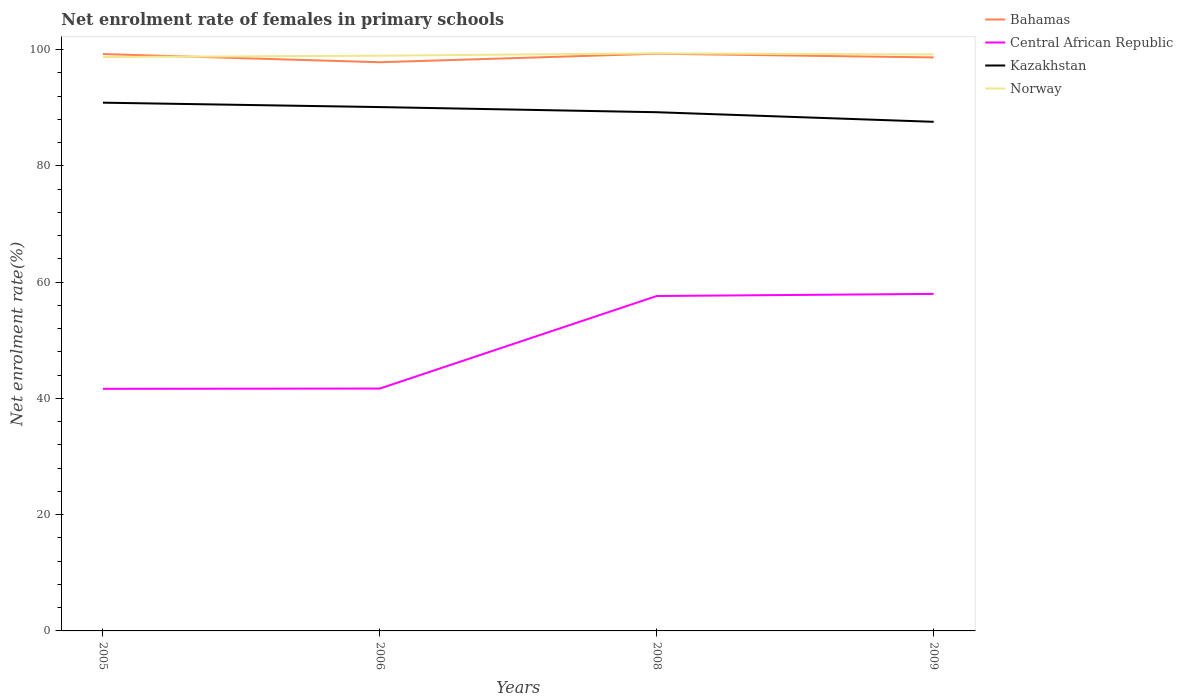Does the line corresponding to Norway intersect with the line corresponding to Bahamas?
Offer a terse response. Yes. Across all years, what is the maximum net enrolment rate of females in primary schools in Norway?
Offer a very short reply. 98.74. What is the total net enrolment rate of females in primary schools in Central African Republic in the graph?
Offer a terse response. -0.05. What is the difference between the highest and the second highest net enrolment rate of females in primary schools in Bahamas?
Give a very brief answer. 1.46. How many lines are there?
Provide a short and direct response. 4. Does the graph contain grids?
Provide a short and direct response. No. How many legend labels are there?
Provide a succinct answer. 4. How are the legend labels stacked?
Your response must be concise. Vertical. What is the title of the graph?
Keep it short and to the point. Net enrolment rate of females in primary schools. What is the label or title of the Y-axis?
Provide a succinct answer. Net enrolment rate(%). What is the Net enrolment rate(%) of Bahamas in 2005?
Ensure brevity in your answer.  99.25. What is the Net enrolment rate(%) in Central African Republic in 2005?
Your answer should be compact. 41.65. What is the Net enrolment rate(%) in Kazakhstan in 2005?
Ensure brevity in your answer.  90.89. What is the Net enrolment rate(%) in Norway in 2005?
Ensure brevity in your answer.  98.74. What is the Net enrolment rate(%) in Bahamas in 2006?
Keep it short and to the point. 97.85. What is the Net enrolment rate(%) of Central African Republic in 2006?
Offer a very short reply. 41.7. What is the Net enrolment rate(%) in Kazakhstan in 2006?
Keep it short and to the point. 90.13. What is the Net enrolment rate(%) of Norway in 2006?
Ensure brevity in your answer.  98.97. What is the Net enrolment rate(%) in Bahamas in 2008?
Give a very brief answer. 99.31. What is the Net enrolment rate(%) in Central African Republic in 2008?
Provide a short and direct response. 57.63. What is the Net enrolment rate(%) in Kazakhstan in 2008?
Offer a terse response. 89.25. What is the Net enrolment rate(%) of Norway in 2008?
Your answer should be very brief. 99.38. What is the Net enrolment rate(%) in Bahamas in 2009?
Give a very brief answer. 98.68. What is the Net enrolment rate(%) of Central African Republic in 2009?
Provide a short and direct response. 57.99. What is the Net enrolment rate(%) in Kazakhstan in 2009?
Provide a short and direct response. 87.6. What is the Net enrolment rate(%) in Norway in 2009?
Offer a very short reply. 99.19. Across all years, what is the maximum Net enrolment rate(%) in Bahamas?
Provide a succinct answer. 99.31. Across all years, what is the maximum Net enrolment rate(%) in Central African Republic?
Keep it short and to the point. 57.99. Across all years, what is the maximum Net enrolment rate(%) in Kazakhstan?
Your answer should be very brief. 90.89. Across all years, what is the maximum Net enrolment rate(%) in Norway?
Provide a short and direct response. 99.38. Across all years, what is the minimum Net enrolment rate(%) in Bahamas?
Offer a very short reply. 97.85. Across all years, what is the minimum Net enrolment rate(%) of Central African Republic?
Your answer should be compact. 41.65. Across all years, what is the minimum Net enrolment rate(%) of Kazakhstan?
Offer a terse response. 87.6. Across all years, what is the minimum Net enrolment rate(%) of Norway?
Provide a succinct answer. 98.74. What is the total Net enrolment rate(%) of Bahamas in the graph?
Offer a terse response. 395.09. What is the total Net enrolment rate(%) in Central African Republic in the graph?
Make the answer very short. 198.97. What is the total Net enrolment rate(%) of Kazakhstan in the graph?
Offer a terse response. 357.87. What is the total Net enrolment rate(%) in Norway in the graph?
Provide a short and direct response. 396.28. What is the difference between the Net enrolment rate(%) in Bahamas in 2005 and that in 2006?
Provide a short and direct response. 1.4. What is the difference between the Net enrolment rate(%) of Central African Republic in 2005 and that in 2006?
Your response must be concise. -0.05. What is the difference between the Net enrolment rate(%) in Kazakhstan in 2005 and that in 2006?
Provide a succinct answer. 0.76. What is the difference between the Net enrolment rate(%) of Norway in 2005 and that in 2006?
Give a very brief answer. -0.23. What is the difference between the Net enrolment rate(%) in Bahamas in 2005 and that in 2008?
Your response must be concise. -0.06. What is the difference between the Net enrolment rate(%) in Central African Republic in 2005 and that in 2008?
Your response must be concise. -15.97. What is the difference between the Net enrolment rate(%) in Kazakhstan in 2005 and that in 2008?
Give a very brief answer. 1.64. What is the difference between the Net enrolment rate(%) of Norway in 2005 and that in 2008?
Offer a very short reply. -0.64. What is the difference between the Net enrolment rate(%) of Bahamas in 2005 and that in 2009?
Keep it short and to the point. 0.58. What is the difference between the Net enrolment rate(%) of Central African Republic in 2005 and that in 2009?
Ensure brevity in your answer.  -16.33. What is the difference between the Net enrolment rate(%) in Kazakhstan in 2005 and that in 2009?
Ensure brevity in your answer.  3.3. What is the difference between the Net enrolment rate(%) in Norway in 2005 and that in 2009?
Make the answer very short. -0.44. What is the difference between the Net enrolment rate(%) of Bahamas in 2006 and that in 2008?
Make the answer very short. -1.46. What is the difference between the Net enrolment rate(%) of Central African Republic in 2006 and that in 2008?
Give a very brief answer. -15.92. What is the difference between the Net enrolment rate(%) of Kazakhstan in 2006 and that in 2008?
Give a very brief answer. 0.88. What is the difference between the Net enrolment rate(%) of Norway in 2006 and that in 2008?
Offer a terse response. -0.4. What is the difference between the Net enrolment rate(%) in Bahamas in 2006 and that in 2009?
Your response must be concise. -0.83. What is the difference between the Net enrolment rate(%) in Central African Republic in 2006 and that in 2009?
Provide a short and direct response. -16.29. What is the difference between the Net enrolment rate(%) in Kazakhstan in 2006 and that in 2009?
Ensure brevity in your answer.  2.54. What is the difference between the Net enrolment rate(%) in Norway in 2006 and that in 2009?
Provide a short and direct response. -0.21. What is the difference between the Net enrolment rate(%) in Bahamas in 2008 and that in 2009?
Ensure brevity in your answer.  0.63. What is the difference between the Net enrolment rate(%) of Central African Republic in 2008 and that in 2009?
Keep it short and to the point. -0.36. What is the difference between the Net enrolment rate(%) in Kazakhstan in 2008 and that in 2009?
Offer a terse response. 1.65. What is the difference between the Net enrolment rate(%) in Norway in 2008 and that in 2009?
Your answer should be compact. 0.19. What is the difference between the Net enrolment rate(%) in Bahamas in 2005 and the Net enrolment rate(%) in Central African Republic in 2006?
Ensure brevity in your answer.  57.55. What is the difference between the Net enrolment rate(%) of Bahamas in 2005 and the Net enrolment rate(%) of Kazakhstan in 2006?
Give a very brief answer. 9.12. What is the difference between the Net enrolment rate(%) in Bahamas in 2005 and the Net enrolment rate(%) in Norway in 2006?
Provide a succinct answer. 0.28. What is the difference between the Net enrolment rate(%) in Central African Republic in 2005 and the Net enrolment rate(%) in Kazakhstan in 2006?
Your answer should be very brief. -48.48. What is the difference between the Net enrolment rate(%) in Central African Republic in 2005 and the Net enrolment rate(%) in Norway in 2006?
Your response must be concise. -57.32. What is the difference between the Net enrolment rate(%) in Kazakhstan in 2005 and the Net enrolment rate(%) in Norway in 2006?
Make the answer very short. -8.08. What is the difference between the Net enrolment rate(%) of Bahamas in 2005 and the Net enrolment rate(%) of Central African Republic in 2008?
Your response must be concise. 41.63. What is the difference between the Net enrolment rate(%) in Bahamas in 2005 and the Net enrolment rate(%) in Kazakhstan in 2008?
Your answer should be very brief. 10.01. What is the difference between the Net enrolment rate(%) in Bahamas in 2005 and the Net enrolment rate(%) in Norway in 2008?
Make the answer very short. -0.12. What is the difference between the Net enrolment rate(%) in Central African Republic in 2005 and the Net enrolment rate(%) in Kazakhstan in 2008?
Provide a succinct answer. -47.59. What is the difference between the Net enrolment rate(%) of Central African Republic in 2005 and the Net enrolment rate(%) of Norway in 2008?
Give a very brief answer. -57.72. What is the difference between the Net enrolment rate(%) in Kazakhstan in 2005 and the Net enrolment rate(%) in Norway in 2008?
Your answer should be compact. -8.49. What is the difference between the Net enrolment rate(%) of Bahamas in 2005 and the Net enrolment rate(%) of Central African Republic in 2009?
Provide a short and direct response. 41.26. What is the difference between the Net enrolment rate(%) of Bahamas in 2005 and the Net enrolment rate(%) of Kazakhstan in 2009?
Provide a short and direct response. 11.66. What is the difference between the Net enrolment rate(%) in Bahamas in 2005 and the Net enrolment rate(%) in Norway in 2009?
Your response must be concise. 0.07. What is the difference between the Net enrolment rate(%) in Central African Republic in 2005 and the Net enrolment rate(%) in Kazakhstan in 2009?
Your answer should be compact. -45.94. What is the difference between the Net enrolment rate(%) in Central African Republic in 2005 and the Net enrolment rate(%) in Norway in 2009?
Ensure brevity in your answer.  -57.53. What is the difference between the Net enrolment rate(%) of Kazakhstan in 2005 and the Net enrolment rate(%) of Norway in 2009?
Your answer should be very brief. -8.29. What is the difference between the Net enrolment rate(%) in Bahamas in 2006 and the Net enrolment rate(%) in Central African Republic in 2008?
Your answer should be very brief. 40.22. What is the difference between the Net enrolment rate(%) of Bahamas in 2006 and the Net enrolment rate(%) of Kazakhstan in 2008?
Give a very brief answer. 8.6. What is the difference between the Net enrolment rate(%) in Bahamas in 2006 and the Net enrolment rate(%) in Norway in 2008?
Your response must be concise. -1.53. What is the difference between the Net enrolment rate(%) of Central African Republic in 2006 and the Net enrolment rate(%) of Kazakhstan in 2008?
Offer a terse response. -47.55. What is the difference between the Net enrolment rate(%) in Central African Republic in 2006 and the Net enrolment rate(%) in Norway in 2008?
Provide a succinct answer. -57.68. What is the difference between the Net enrolment rate(%) in Kazakhstan in 2006 and the Net enrolment rate(%) in Norway in 2008?
Keep it short and to the point. -9.25. What is the difference between the Net enrolment rate(%) of Bahamas in 2006 and the Net enrolment rate(%) of Central African Republic in 2009?
Make the answer very short. 39.86. What is the difference between the Net enrolment rate(%) of Bahamas in 2006 and the Net enrolment rate(%) of Kazakhstan in 2009?
Provide a short and direct response. 10.25. What is the difference between the Net enrolment rate(%) in Bahamas in 2006 and the Net enrolment rate(%) in Norway in 2009?
Give a very brief answer. -1.34. What is the difference between the Net enrolment rate(%) in Central African Republic in 2006 and the Net enrolment rate(%) in Kazakhstan in 2009?
Ensure brevity in your answer.  -45.89. What is the difference between the Net enrolment rate(%) of Central African Republic in 2006 and the Net enrolment rate(%) of Norway in 2009?
Keep it short and to the point. -57.48. What is the difference between the Net enrolment rate(%) of Kazakhstan in 2006 and the Net enrolment rate(%) of Norway in 2009?
Provide a succinct answer. -9.05. What is the difference between the Net enrolment rate(%) in Bahamas in 2008 and the Net enrolment rate(%) in Central African Republic in 2009?
Provide a short and direct response. 41.32. What is the difference between the Net enrolment rate(%) of Bahamas in 2008 and the Net enrolment rate(%) of Kazakhstan in 2009?
Your answer should be very brief. 11.72. What is the difference between the Net enrolment rate(%) of Bahamas in 2008 and the Net enrolment rate(%) of Norway in 2009?
Offer a very short reply. 0.13. What is the difference between the Net enrolment rate(%) in Central African Republic in 2008 and the Net enrolment rate(%) in Kazakhstan in 2009?
Your response must be concise. -29.97. What is the difference between the Net enrolment rate(%) in Central African Republic in 2008 and the Net enrolment rate(%) in Norway in 2009?
Provide a succinct answer. -41.56. What is the difference between the Net enrolment rate(%) of Kazakhstan in 2008 and the Net enrolment rate(%) of Norway in 2009?
Give a very brief answer. -9.94. What is the average Net enrolment rate(%) in Bahamas per year?
Your answer should be compact. 98.77. What is the average Net enrolment rate(%) in Central African Republic per year?
Your response must be concise. 49.74. What is the average Net enrolment rate(%) in Kazakhstan per year?
Give a very brief answer. 89.47. What is the average Net enrolment rate(%) of Norway per year?
Provide a succinct answer. 99.07. In the year 2005, what is the difference between the Net enrolment rate(%) of Bahamas and Net enrolment rate(%) of Central African Republic?
Give a very brief answer. 57.6. In the year 2005, what is the difference between the Net enrolment rate(%) of Bahamas and Net enrolment rate(%) of Kazakhstan?
Keep it short and to the point. 8.36. In the year 2005, what is the difference between the Net enrolment rate(%) in Bahamas and Net enrolment rate(%) in Norway?
Offer a terse response. 0.51. In the year 2005, what is the difference between the Net enrolment rate(%) in Central African Republic and Net enrolment rate(%) in Kazakhstan?
Your answer should be very brief. -49.24. In the year 2005, what is the difference between the Net enrolment rate(%) of Central African Republic and Net enrolment rate(%) of Norway?
Your response must be concise. -57.09. In the year 2005, what is the difference between the Net enrolment rate(%) of Kazakhstan and Net enrolment rate(%) of Norway?
Make the answer very short. -7.85. In the year 2006, what is the difference between the Net enrolment rate(%) of Bahamas and Net enrolment rate(%) of Central African Republic?
Provide a succinct answer. 56.15. In the year 2006, what is the difference between the Net enrolment rate(%) in Bahamas and Net enrolment rate(%) in Kazakhstan?
Your answer should be very brief. 7.72. In the year 2006, what is the difference between the Net enrolment rate(%) in Bahamas and Net enrolment rate(%) in Norway?
Ensure brevity in your answer.  -1.12. In the year 2006, what is the difference between the Net enrolment rate(%) in Central African Republic and Net enrolment rate(%) in Kazakhstan?
Give a very brief answer. -48.43. In the year 2006, what is the difference between the Net enrolment rate(%) of Central African Republic and Net enrolment rate(%) of Norway?
Your answer should be very brief. -57.27. In the year 2006, what is the difference between the Net enrolment rate(%) of Kazakhstan and Net enrolment rate(%) of Norway?
Offer a very short reply. -8.84. In the year 2008, what is the difference between the Net enrolment rate(%) of Bahamas and Net enrolment rate(%) of Central African Republic?
Ensure brevity in your answer.  41.69. In the year 2008, what is the difference between the Net enrolment rate(%) in Bahamas and Net enrolment rate(%) in Kazakhstan?
Your answer should be very brief. 10.06. In the year 2008, what is the difference between the Net enrolment rate(%) in Bahamas and Net enrolment rate(%) in Norway?
Keep it short and to the point. -0.06. In the year 2008, what is the difference between the Net enrolment rate(%) of Central African Republic and Net enrolment rate(%) of Kazakhstan?
Keep it short and to the point. -31.62. In the year 2008, what is the difference between the Net enrolment rate(%) of Central African Republic and Net enrolment rate(%) of Norway?
Make the answer very short. -41.75. In the year 2008, what is the difference between the Net enrolment rate(%) of Kazakhstan and Net enrolment rate(%) of Norway?
Your answer should be very brief. -10.13. In the year 2009, what is the difference between the Net enrolment rate(%) of Bahamas and Net enrolment rate(%) of Central African Republic?
Provide a short and direct response. 40.69. In the year 2009, what is the difference between the Net enrolment rate(%) of Bahamas and Net enrolment rate(%) of Kazakhstan?
Offer a terse response. 11.08. In the year 2009, what is the difference between the Net enrolment rate(%) of Bahamas and Net enrolment rate(%) of Norway?
Offer a terse response. -0.51. In the year 2009, what is the difference between the Net enrolment rate(%) of Central African Republic and Net enrolment rate(%) of Kazakhstan?
Your answer should be very brief. -29.61. In the year 2009, what is the difference between the Net enrolment rate(%) of Central African Republic and Net enrolment rate(%) of Norway?
Your answer should be very brief. -41.2. In the year 2009, what is the difference between the Net enrolment rate(%) in Kazakhstan and Net enrolment rate(%) in Norway?
Your answer should be very brief. -11.59. What is the ratio of the Net enrolment rate(%) of Bahamas in 2005 to that in 2006?
Ensure brevity in your answer.  1.01. What is the ratio of the Net enrolment rate(%) in Kazakhstan in 2005 to that in 2006?
Make the answer very short. 1.01. What is the ratio of the Net enrolment rate(%) of Central African Republic in 2005 to that in 2008?
Offer a very short reply. 0.72. What is the ratio of the Net enrolment rate(%) in Kazakhstan in 2005 to that in 2008?
Make the answer very short. 1.02. What is the ratio of the Net enrolment rate(%) of Central African Republic in 2005 to that in 2009?
Ensure brevity in your answer.  0.72. What is the ratio of the Net enrolment rate(%) of Kazakhstan in 2005 to that in 2009?
Your answer should be compact. 1.04. What is the ratio of the Net enrolment rate(%) of Norway in 2005 to that in 2009?
Make the answer very short. 1. What is the ratio of the Net enrolment rate(%) in Bahamas in 2006 to that in 2008?
Keep it short and to the point. 0.99. What is the ratio of the Net enrolment rate(%) in Central African Republic in 2006 to that in 2008?
Provide a short and direct response. 0.72. What is the ratio of the Net enrolment rate(%) of Kazakhstan in 2006 to that in 2008?
Your answer should be compact. 1.01. What is the ratio of the Net enrolment rate(%) of Norway in 2006 to that in 2008?
Ensure brevity in your answer.  1. What is the ratio of the Net enrolment rate(%) of Bahamas in 2006 to that in 2009?
Give a very brief answer. 0.99. What is the ratio of the Net enrolment rate(%) in Central African Republic in 2006 to that in 2009?
Your answer should be compact. 0.72. What is the ratio of the Net enrolment rate(%) in Kazakhstan in 2006 to that in 2009?
Your response must be concise. 1.03. What is the ratio of the Net enrolment rate(%) in Norway in 2006 to that in 2009?
Your response must be concise. 1. What is the ratio of the Net enrolment rate(%) in Bahamas in 2008 to that in 2009?
Your answer should be very brief. 1.01. What is the ratio of the Net enrolment rate(%) in Kazakhstan in 2008 to that in 2009?
Give a very brief answer. 1.02. What is the difference between the highest and the second highest Net enrolment rate(%) of Bahamas?
Provide a succinct answer. 0.06. What is the difference between the highest and the second highest Net enrolment rate(%) of Central African Republic?
Provide a succinct answer. 0.36. What is the difference between the highest and the second highest Net enrolment rate(%) of Kazakhstan?
Provide a short and direct response. 0.76. What is the difference between the highest and the second highest Net enrolment rate(%) of Norway?
Ensure brevity in your answer.  0.19. What is the difference between the highest and the lowest Net enrolment rate(%) in Bahamas?
Your answer should be very brief. 1.46. What is the difference between the highest and the lowest Net enrolment rate(%) of Central African Republic?
Your response must be concise. 16.33. What is the difference between the highest and the lowest Net enrolment rate(%) in Kazakhstan?
Provide a succinct answer. 3.3. What is the difference between the highest and the lowest Net enrolment rate(%) of Norway?
Your answer should be very brief. 0.64. 